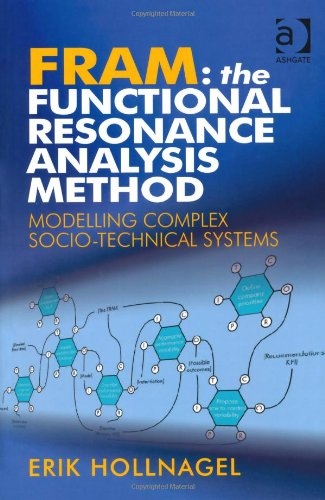What is the primary method discussed in this book for analyzing complex systems? The primary method discussed in the book is the Functional Resonance Analysis Method (FRAM), which is designed to identify and analyze the variability and interdependencies within complex socio-technical systems. 